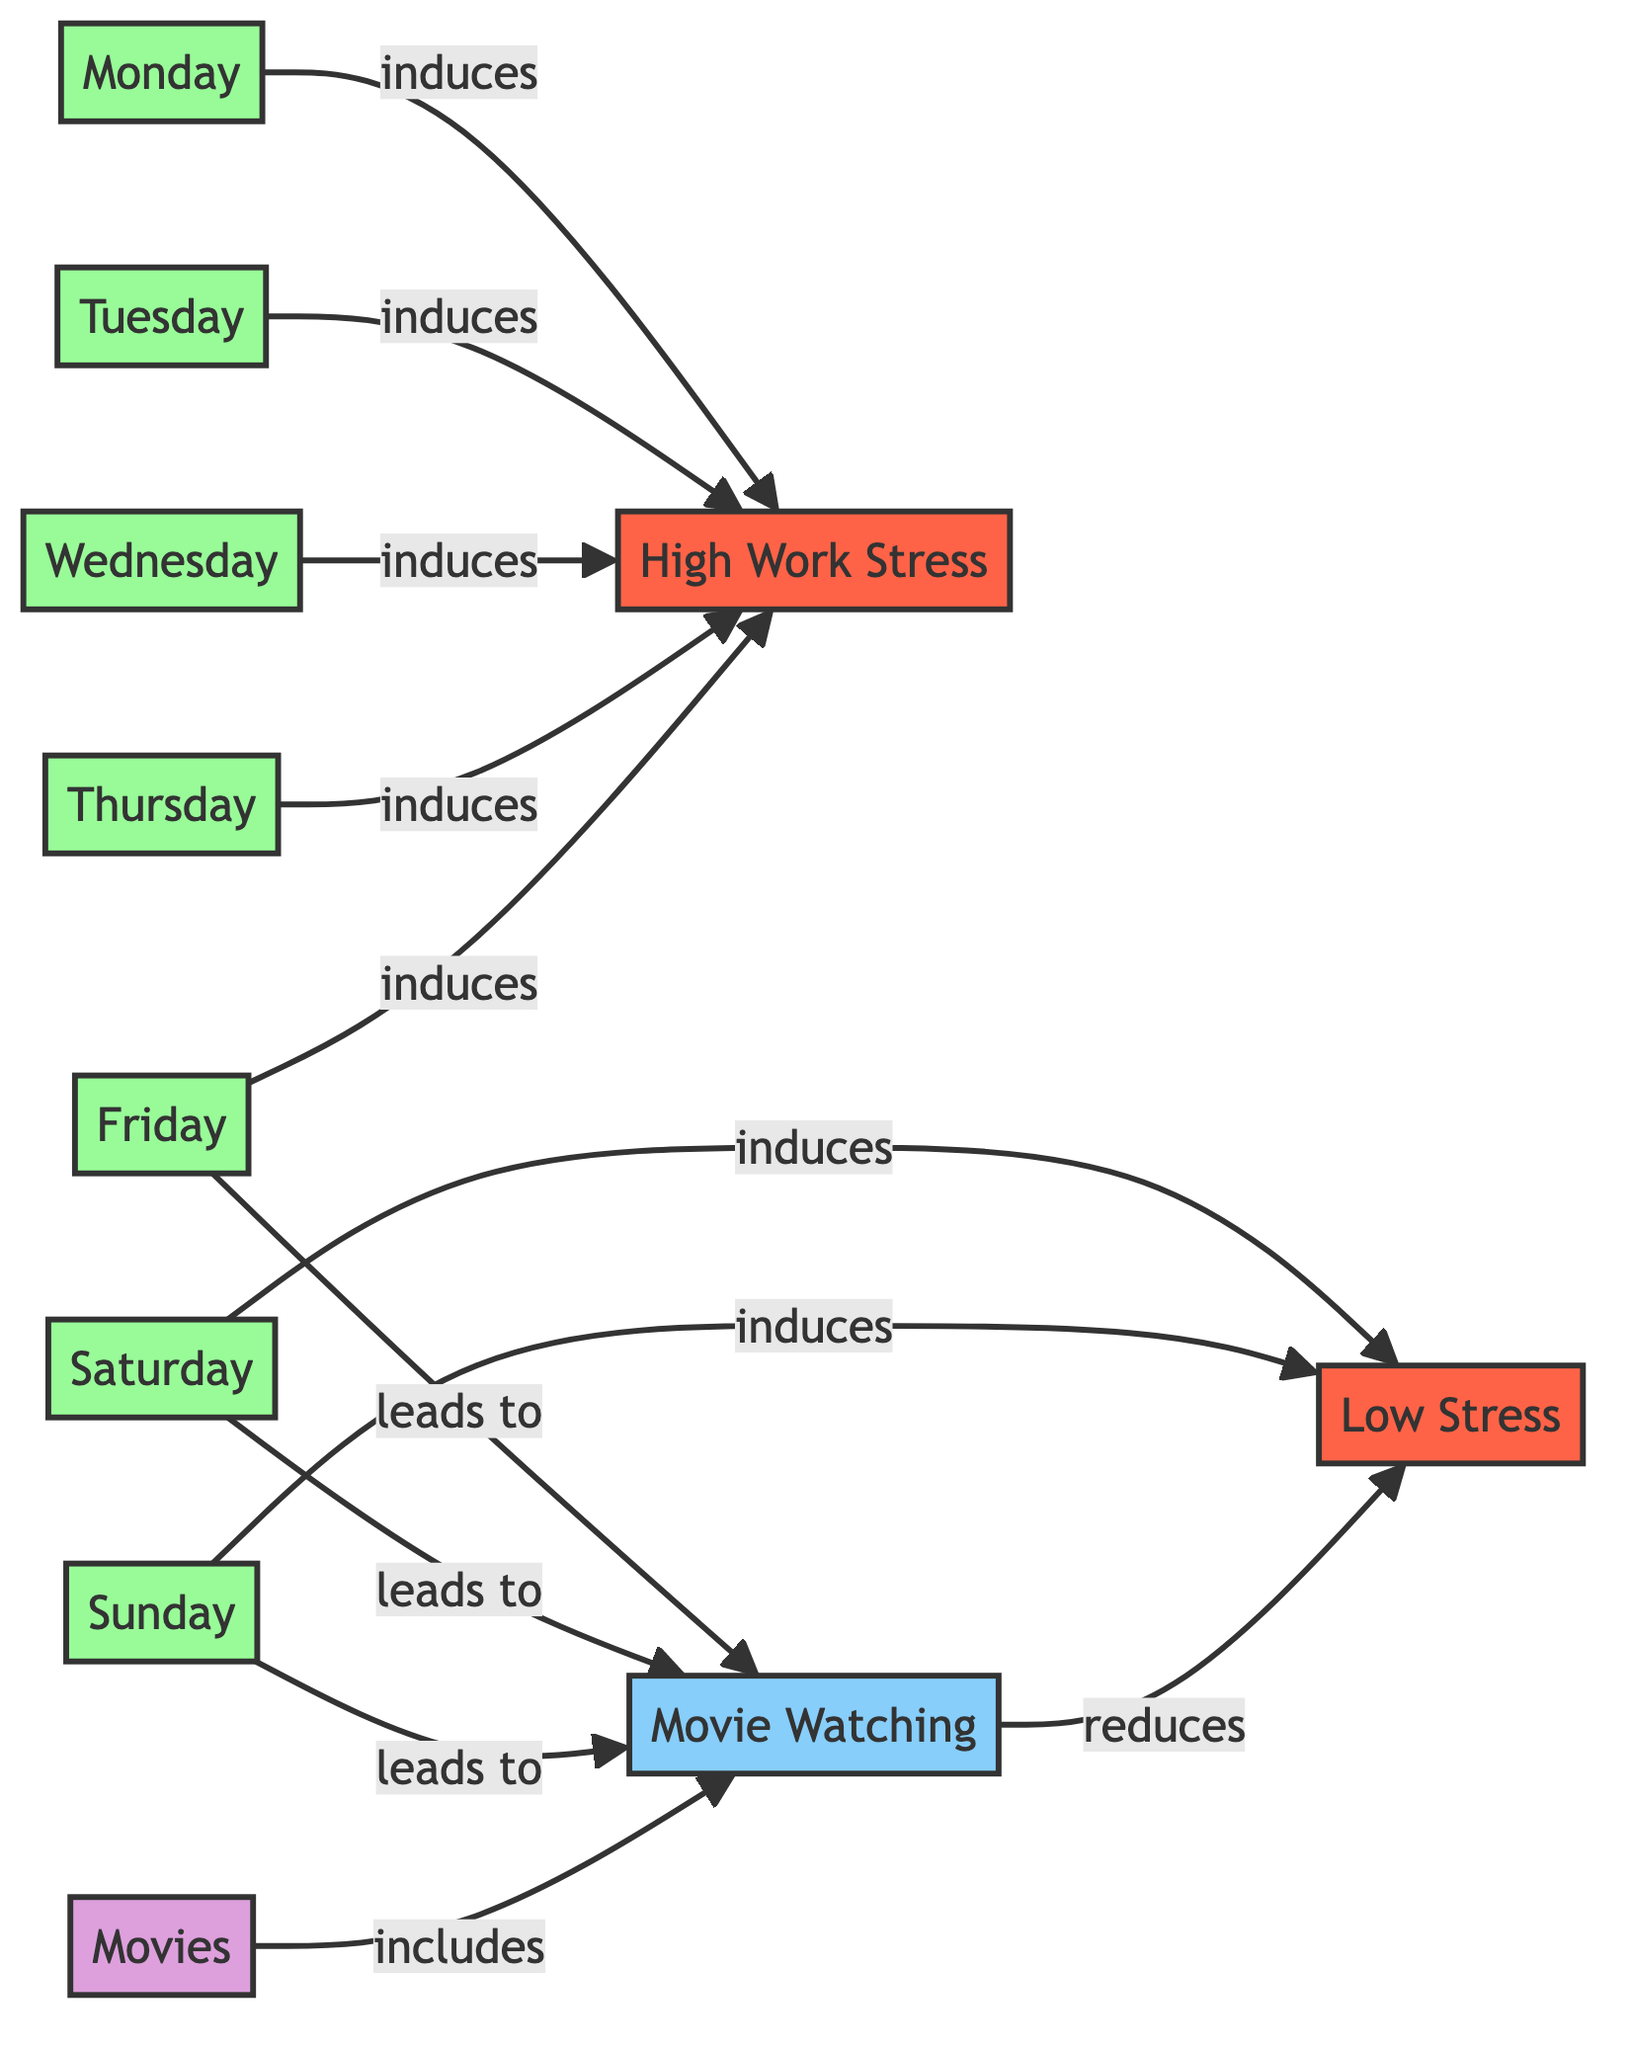What induces High Work Stress? The diagram shows that Monday, Tuesday, Wednesday, Thursday, and Friday each have a directed edge labeled "induces" leading to the node "High Work Stress." Therefore, each of these weekdays is responsible for inducing high work stress.
Answer: Monday, Tuesday, Wednesday, Thursday, Friday Which days lead to Movie Watching? The directed edges from Friday, Saturday, and Sunday all point to the node "Movie Watching," indicating that these are the days where movie watching occurs.
Answer: Friday, Saturday, Sunday How many nodes represent weekdays? The diagram lists Monday, Tuesday, Wednesday, Thursday, and Friday as nodes categorized under type "day." Counting these gives a total of five nodes that represent weekdays.
Answer: 5 What reduces Low Stress? The diagram indicates that the node "Movie Watching" has a directed edge labeled "reduces" pointing to "Low Stress." Thus, engaging in movie watching is what reduces stress levels during the weekend.
Answer: Movie Watching How many total activities are included in Movies? The directed edge labeled "includes" leads from the node "Movies" to "Movie Watching," suggesting that the activity of movie watching is summed up under movies. There is only one activity indicated in this relationship.
Answer: 1 Which time period is associated with Weekend Relaxation? The nodes Saturday and Sunday both induce "Low Stress," leading us to conclude that the weekend is the associated time period for weekend relaxation.
Answer: Weekend Which day induces Low Stress? The diagram shows that both Saturday and Sunday have directed edges leading to "Low Stress," indicating that these days induce relaxation on the weekend.
Answer: Saturday, Sunday What is the relationship between Movie Watching and Weekend Relaxation? The directed edge indicates that "Movie Watching" reduces "Low Stress." This means that the activity of watching movies contributes to lower levels of stress.
Answer: reduces 